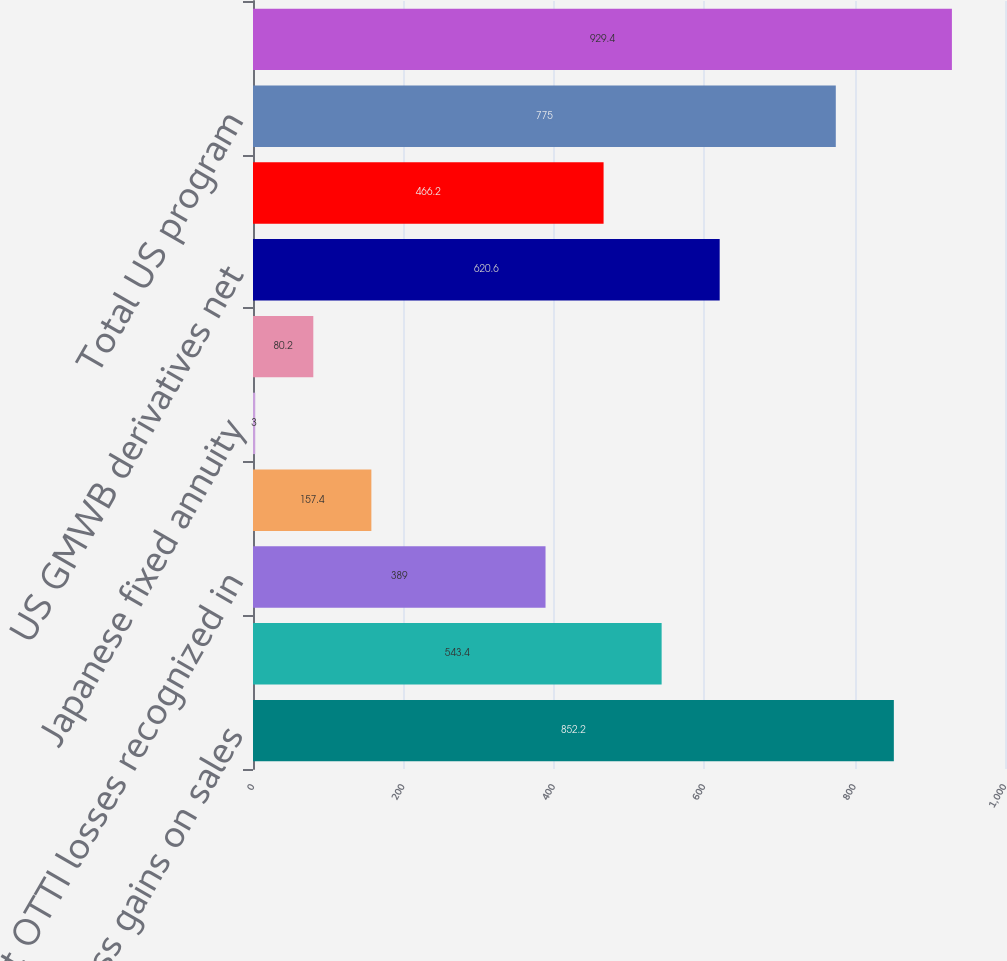Convert chart. <chart><loc_0><loc_0><loc_500><loc_500><bar_chart><fcel>Gross gains on sales<fcel>Gross losses on sales<fcel>Net OTTI losses recognized in<fcel>Valuation allowances on<fcel>Japanese fixed annuity<fcel>Periodic net coupon<fcel>US GMWB derivatives net<fcel>US macro hedge program<fcel>Total US program<fcel>International program<nl><fcel>852.2<fcel>543.4<fcel>389<fcel>157.4<fcel>3<fcel>80.2<fcel>620.6<fcel>466.2<fcel>775<fcel>929.4<nl></chart> 